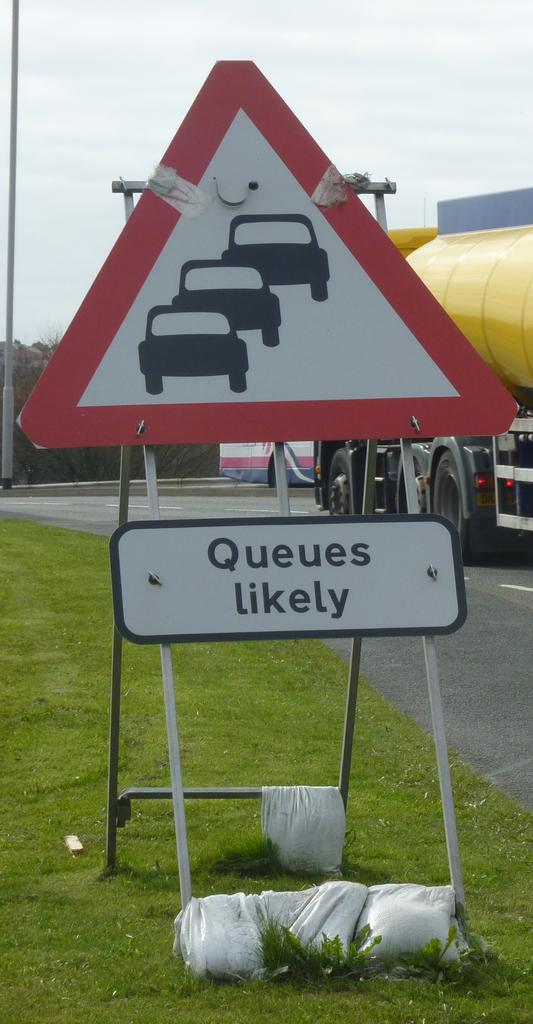<image>
Describe the image concisely. a yield sign has queues likely sits by the road 